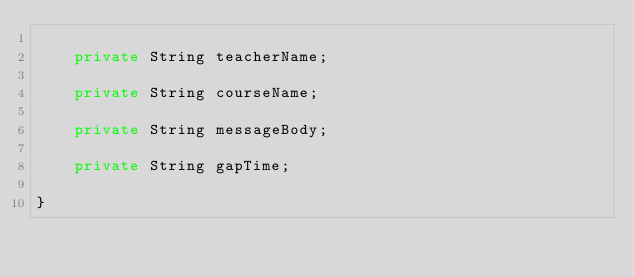<code> <loc_0><loc_0><loc_500><loc_500><_Java_>
    private String teacherName;

    private String courseName;

    private String messageBody;

    private String gapTime;

}
</code> 